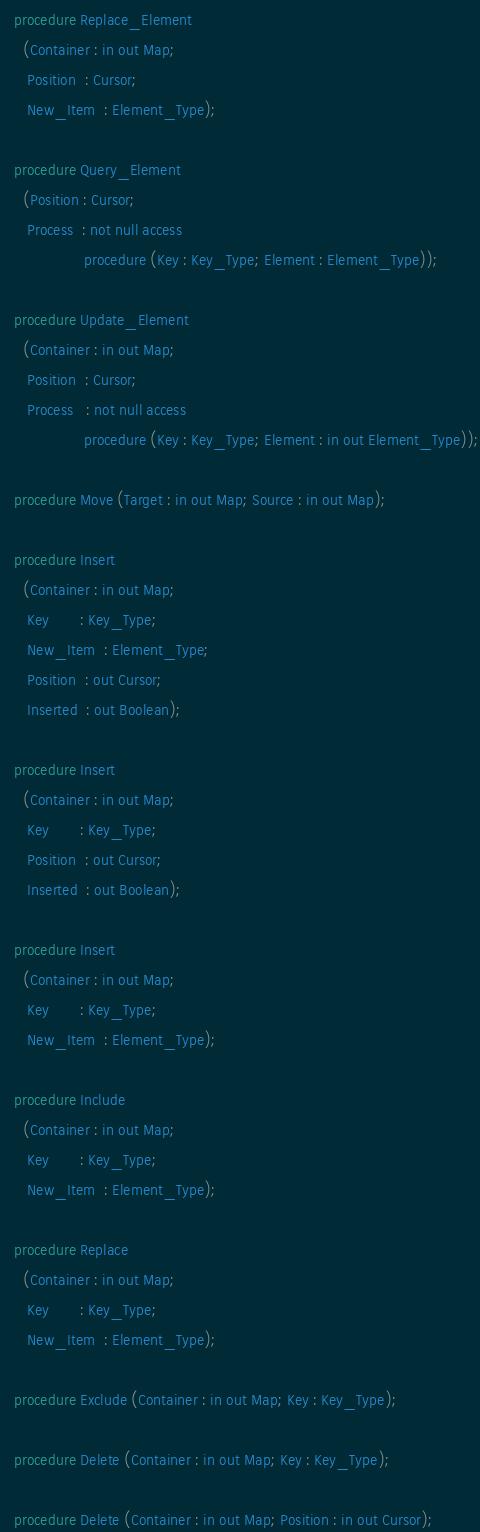Convert code to text. <code><loc_0><loc_0><loc_500><loc_500><_Ada_>
   procedure Replace_Element
     (Container : in out Map;
      Position  : Cursor;
      New_Item  : Element_Type);

   procedure Query_Element
     (Position : Cursor;
      Process  : not null access
                   procedure (Key : Key_Type; Element : Element_Type));

   procedure Update_Element
     (Container : in out Map;
      Position  : Cursor;
      Process   : not null access
                   procedure (Key : Key_Type; Element : in out Element_Type));

   procedure Move (Target : in out Map; Source : in out Map);

   procedure Insert
     (Container : in out Map;
      Key       : Key_Type;
      New_Item  : Element_Type;
      Position  : out Cursor;
      Inserted  : out Boolean);

   procedure Insert
     (Container : in out Map;
      Key       : Key_Type;
      Position  : out Cursor;
      Inserted  : out Boolean);

   procedure Insert
     (Container : in out Map;
      Key       : Key_Type;
      New_Item  : Element_Type);

   procedure Include
     (Container : in out Map;
      Key       : Key_Type;
      New_Item  : Element_Type);

   procedure Replace
     (Container : in out Map;
      Key       : Key_Type;
      New_Item  : Element_Type);

   procedure Exclude (Container : in out Map; Key : Key_Type);

   procedure Delete (Container : in out Map; Key : Key_Type);

   procedure Delete (Container : in out Map; Position : in out Cursor);
</code> 